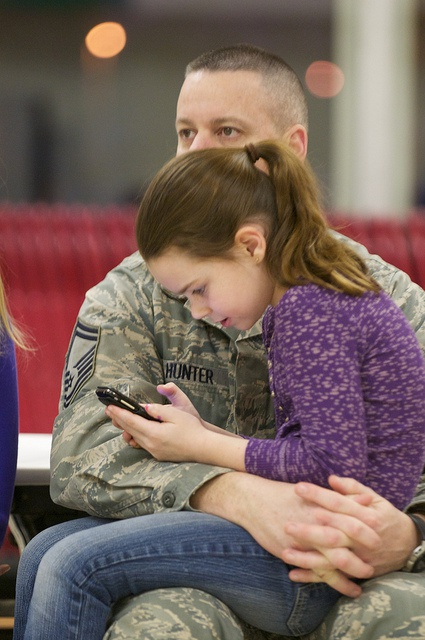Describe the objects in this image and their specific colors. I can see people in black and purple tones, people in black, gray, tan, and darkgray tones, couch in black, brown, and maroon tones, and cell phone in black, gray, and maroon tones in this image. 